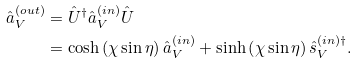Convert formula to latex. <formula><loc_0><loc_0><loc_500><loc_500>\hat { a } _ { V } ^ { \left ( o u t \right ) } & = \hat { U } ^ { \dag } \hat { a } _ { V } ^ { \left ( i n \right ) } \hat { U } \\ & = \cosh \left ( \chi \sin \eta \right ) \hat { a } _ { V } ^ { \left ( i n \right ) } + \sinh \left ( \chi \sin \eta \right ) \hat { s } _ { V } ^ { \left ( i n \right ) \dag } .</formula> 